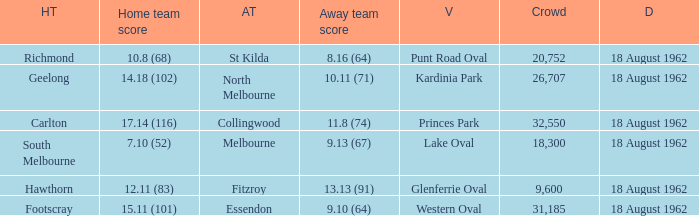Would you mind parsing the complete table? {'header': ['HT', 'Home team score', 'AT', 'Away team score', 'V', 'Crowd', 'D'], 'rows': [['Richmond', '10.8 (68)', 'St Kilda', '8.16 (64)', 'Punt Road Oval', '20,752', '18 August 1962'], ['Geelong', '14.18 (102)', 'North Melbourne', '10.11 (71)', 'Kardinia Park', '26,707', '18 August 1962'], ['Carlton', '17.14 (116)', 'Collingwood', '11.8 (74)', 'Princes Park', '32,550', '18 August 1962'], ['South Melbourne', '7.10 (52)', 'Melbourne', '9.13 (67)', 'Lake Oval', '18,300', '18 August 1962'], ['Hawthorn', '12.11 (83)', 'Fitzroy', '13.13 (91)', 'Glenferrie Oval', '9,600', '18 August 1962'], ['Footscray', '15.11 (101)', 'Essendon', '9.10 (64)', 'Western Oval', '31,185', '18 August 1962']]} What was the away team when the home team scored 10.8 (68)? St Kilda. 